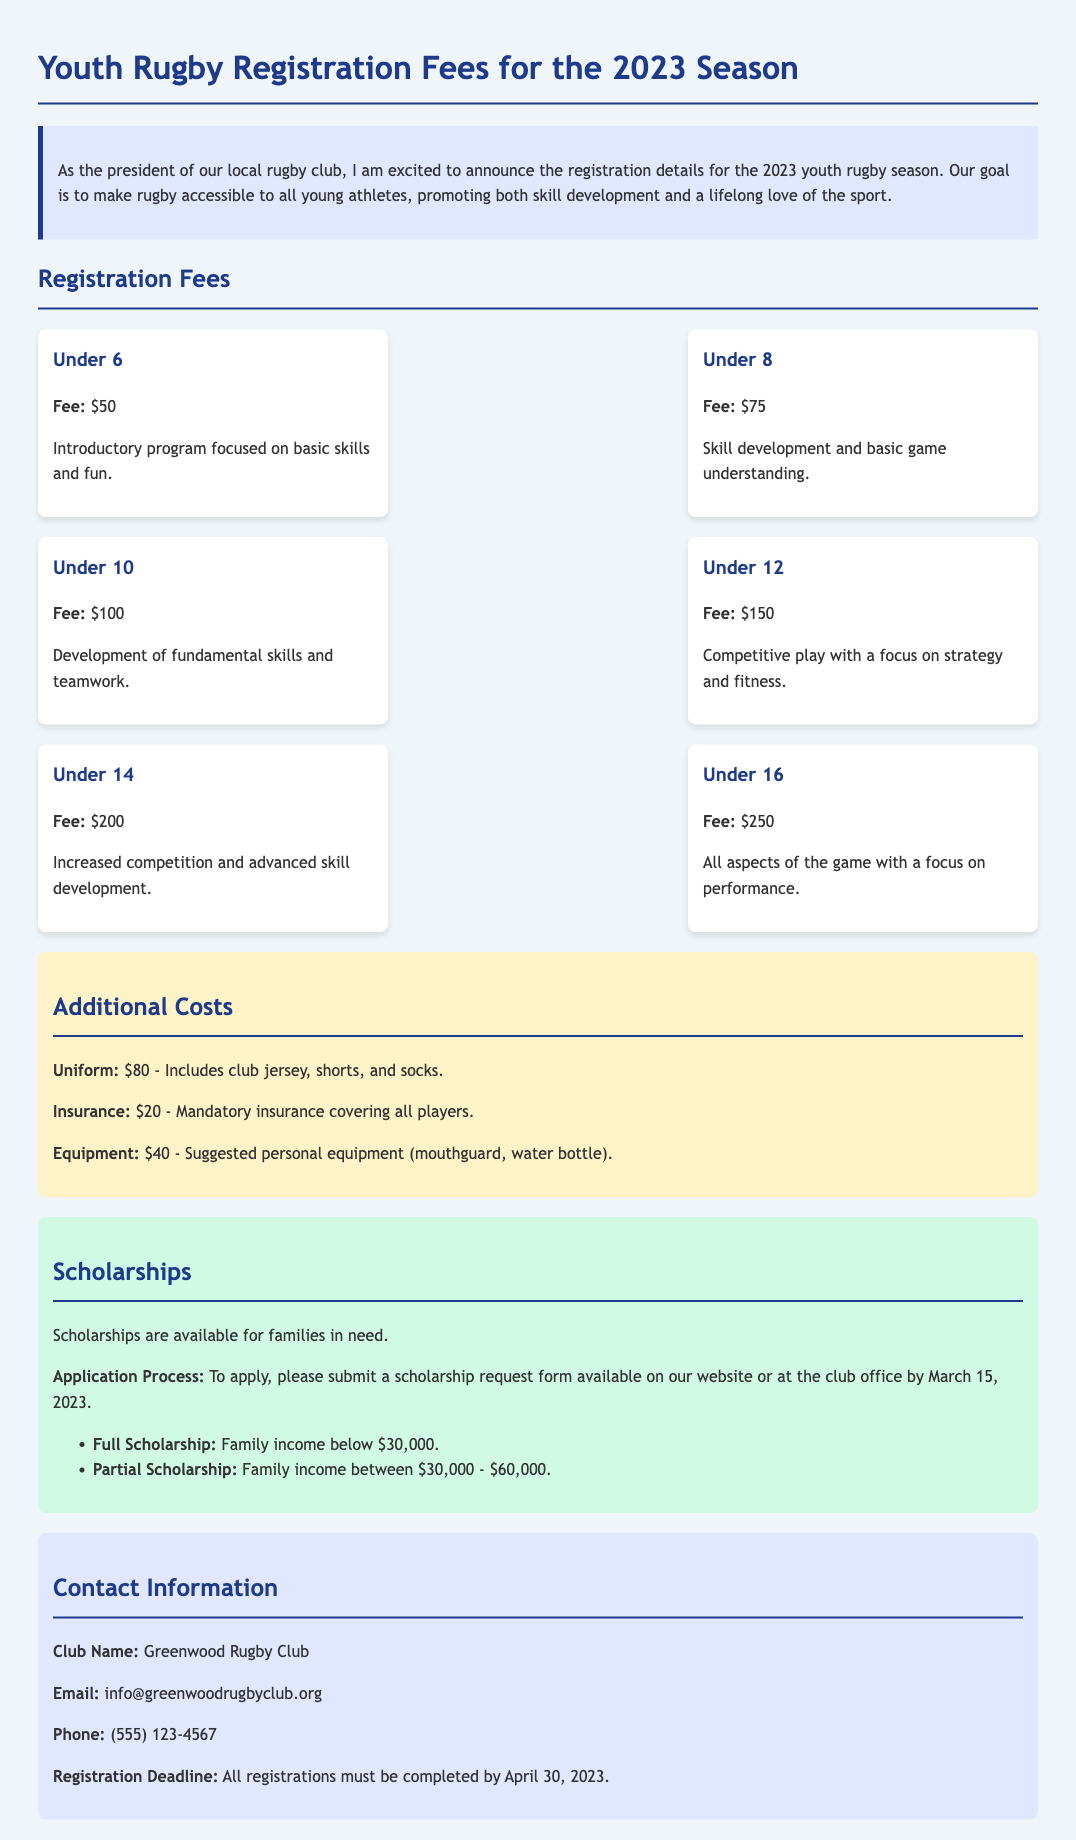What is the fee for Under 12? The fee for Under 12 is specifically stated in the document as $150.
Answer: $150 What is the insurance cost? The document specifies that the insurance cost is $20, making it a straightforward answer.
Answer: $20 What is the registration deadline? The document mentions that the registration deadline is April 30, 2023.
Answer: April 30, 2023 What is the requirement for a full scholarship? The document outlines that a full scholarship is available for families with income below $30,000.
Answer: Below $30,000 How much is the uniform cost? The document clearly states that the uniform cost is $80.
Answer: $80 What age group has the highest registration fee? By reviewing the fees for each age group, it is clear that the Under 16 category has the highest fee at $250.
Answer: Under 16 What is included in the suggested personal equipment? The document specifies that suggested personal equipment includes a mouthguard and water bottle.
Answer: Mouthguard, water bottle Where can scholarship application forms be obtained? According to the document, scholarship request forms are available on the website or at the club office.
Answer: Website or club office What is the total cost for Under 10 registration, uniform, and insurance? To find the total we add the Under 10 fee ($100), uniform ($80), and insurance ($20) which equals $200.
Answer: $200 